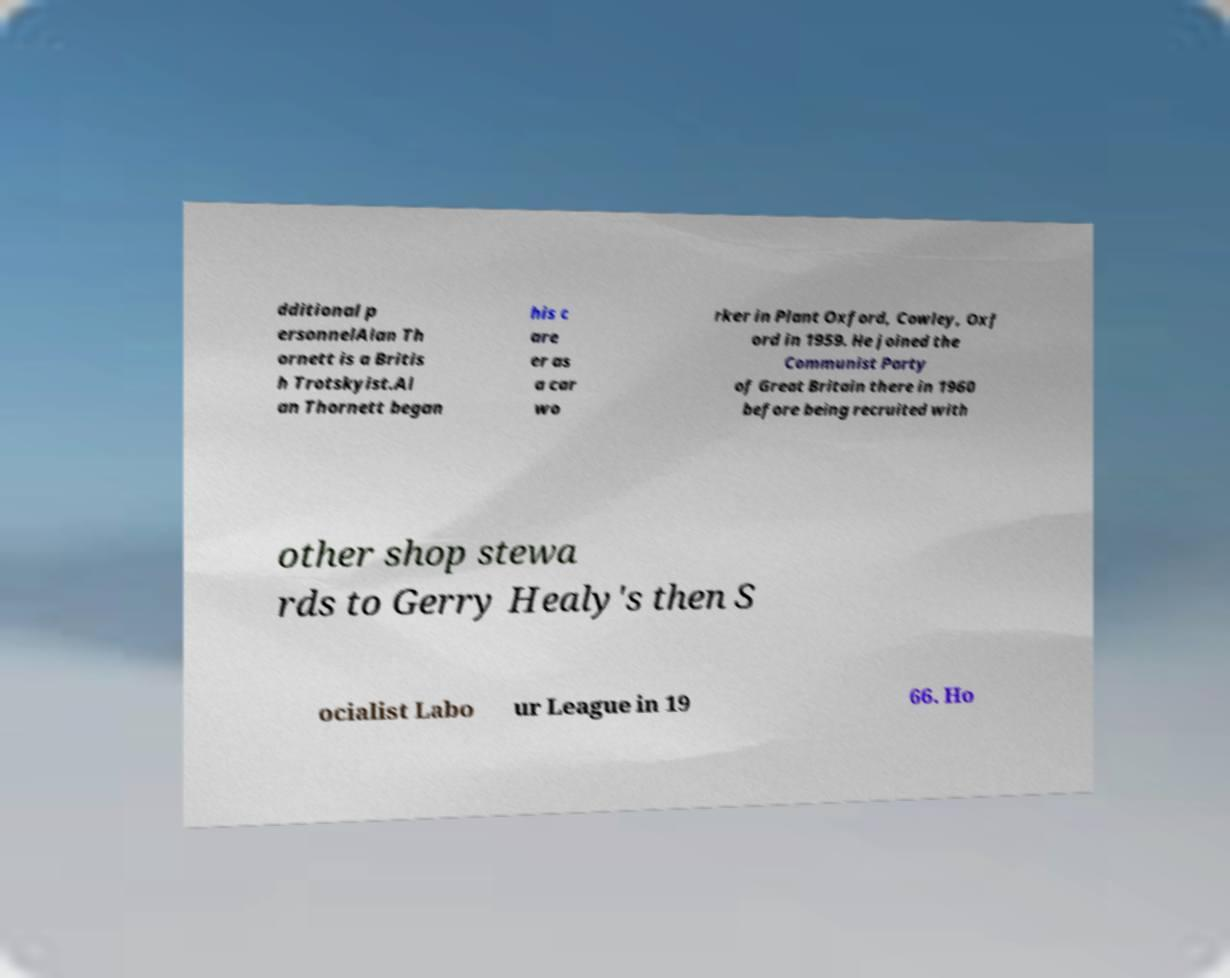Can you read and provide the text displayed in the image?This photo seems to have some interesting text. Can you extract and type it out for me? dditional p ersonnelAlan Th ornett is a Britis h Trotskyist.Al an Thornett began his c are er as a car wo rker in Plant Oxford, Cowley, Oxf ord in 1959. He joined the Communist Party of Great Britain there in 1960 before being recruited with other shop stewa rds to Gerry Healy's then S ocialist Labo ur League in 19 66. Ho 